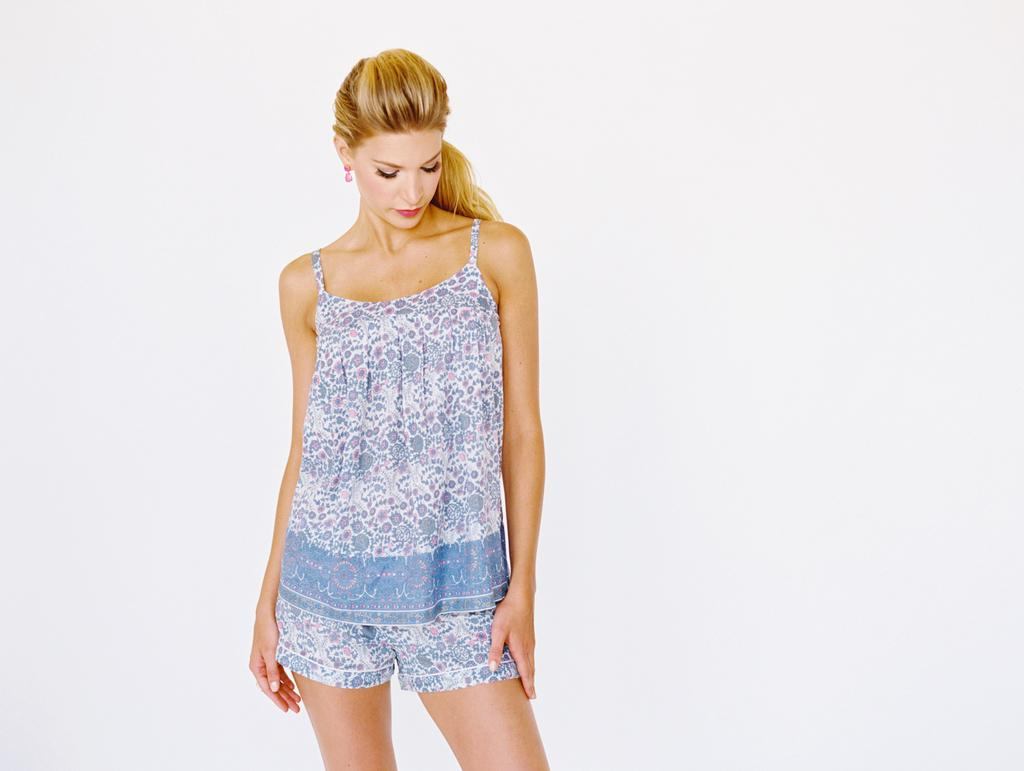Who is present in the image? There is a woman in the image. What is the woman wearing? The woman is wearing a blue dress. Where is the woman located in the image? The woman is standing near a wall. What is the scent of the flowers in the park in the image? There is no park or flowers present in the image; it features a woman standing near a wall. 